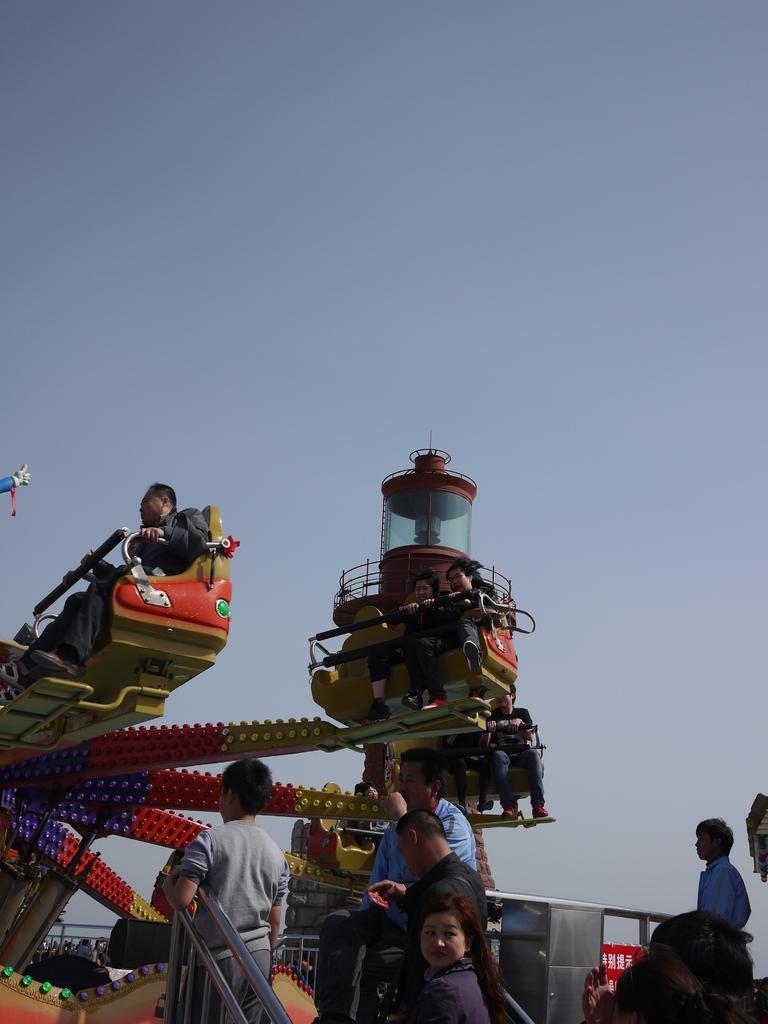In one or two sentences, can you explain what this image depicts? In this image, in the middle, we can see group of people standing. On the right side corner, we can also see group of people. On the left side and on the middle, we can see group of people sitting on a machine. On the top there is a sky. 